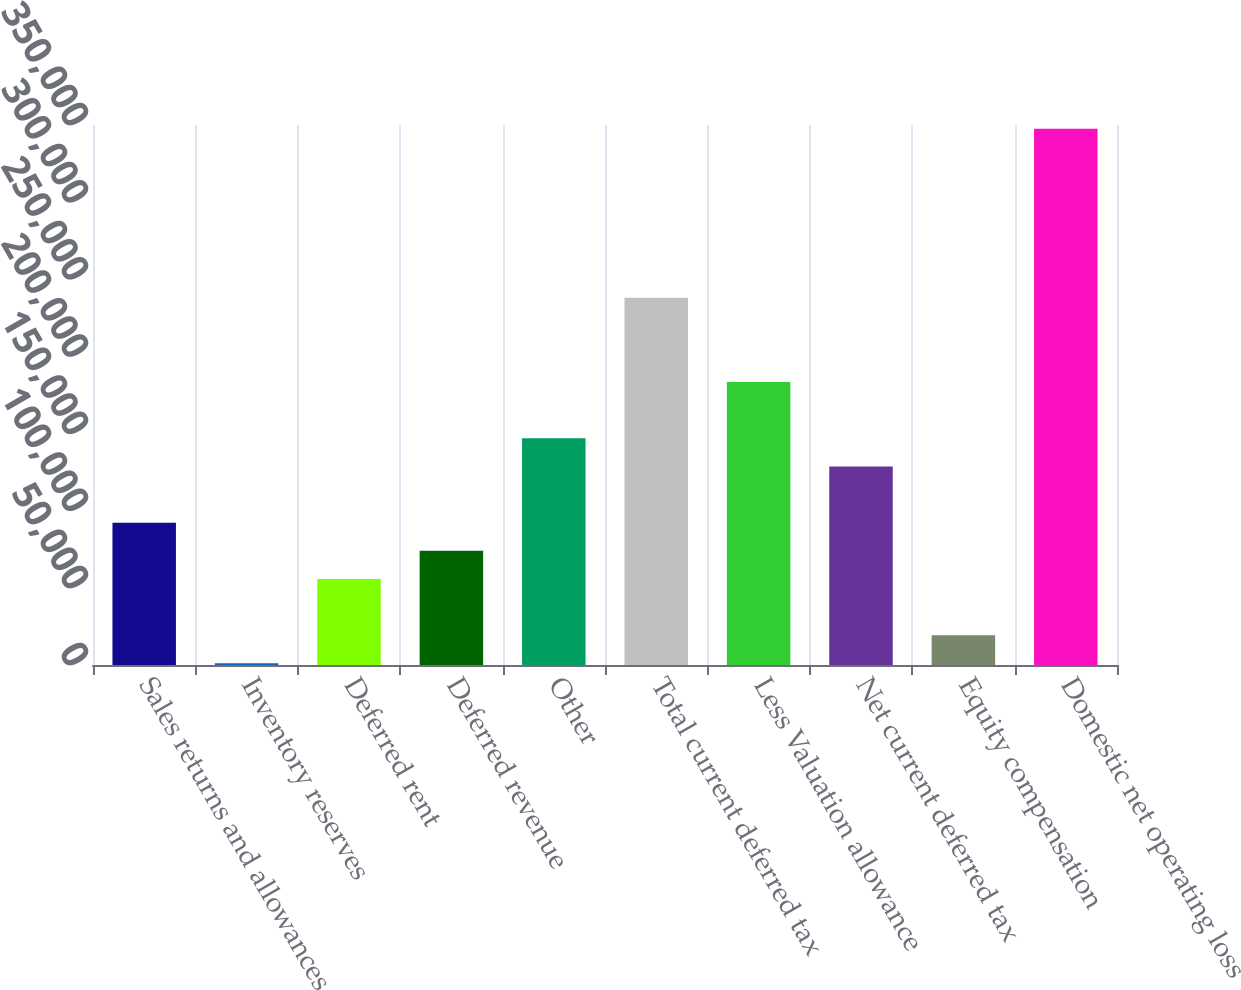<chart> <loc_0><loc_0><loc_500><loc_500><bar_chart><fcel>Sales returns and allowances<fcel>Inventory reserves<fcel>Deferred rent<fcel>Deferred revenue<fcel>Other<fcel>Total current deferred tax<fcel>Less Valuation allowance<fcel>Net current deferred tax<fcel>Equity compensation<fcel>Domestic net operating loss<nl><fcel>92221.5<fcel>1054<fcel>55754.5<fcel>73988<fcel>146922<fcel>238090<fcel>183389<fcel>128688<fcel>19287.5<fcel>347490<nl></chart> 